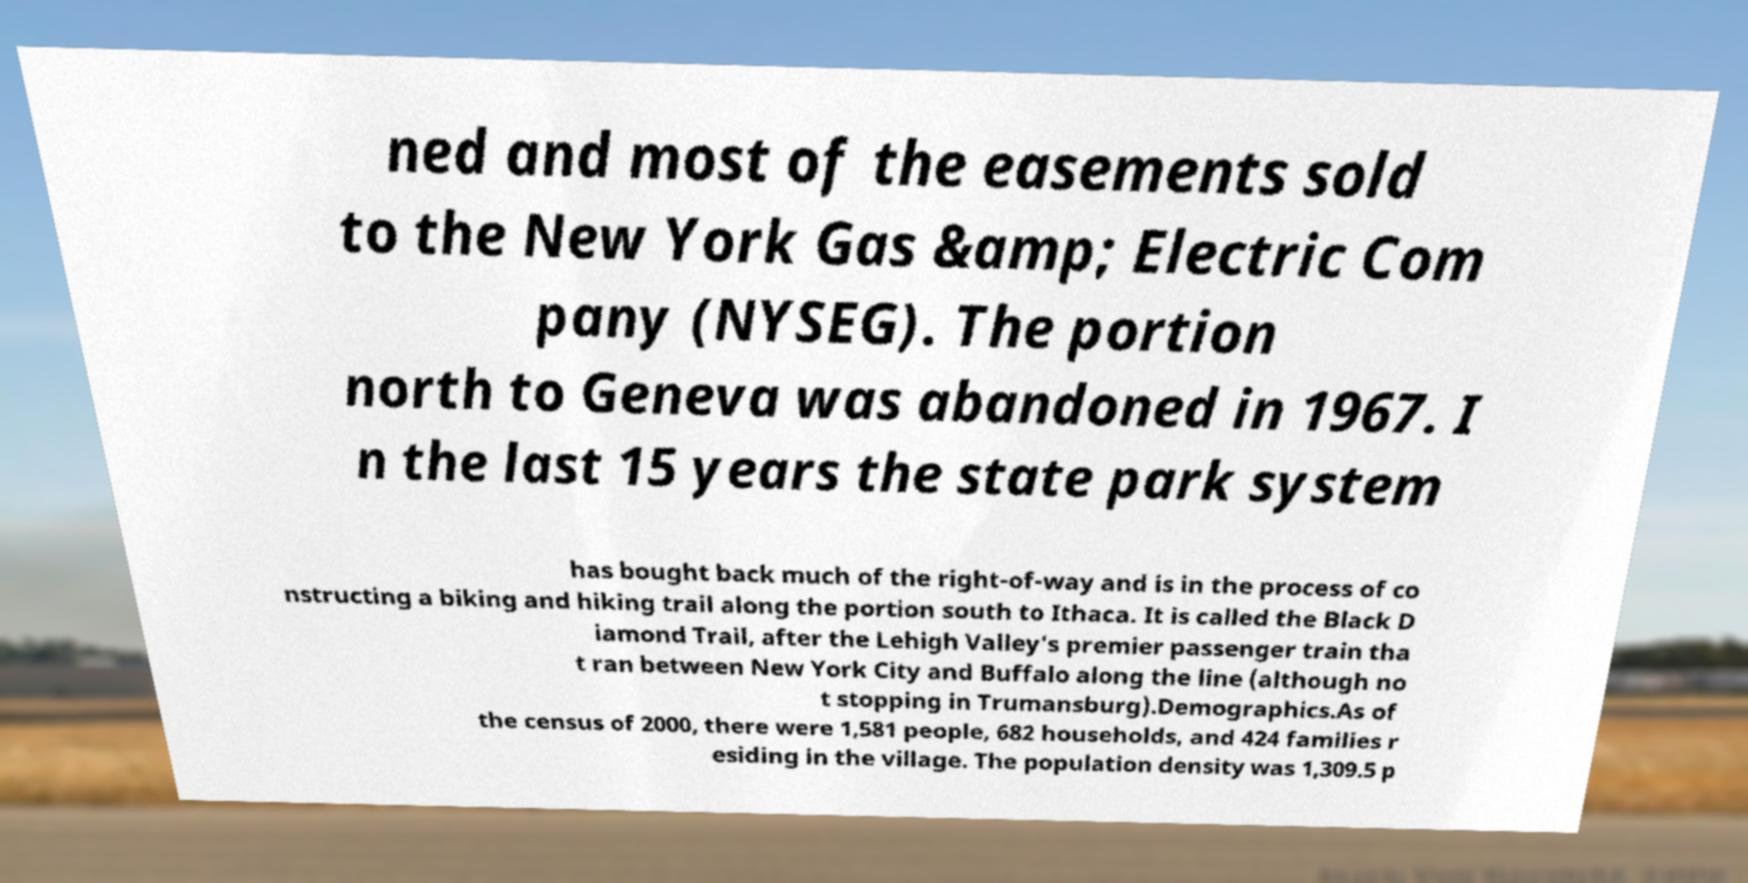Could you assist in decoding the text presented in this image and type it out clearly? ned and most of the easements sold to the New York Gas &amp; Electric Com pany (NYSEG). The portion north to Geneva was abandoned in 1967. I n the last 15 years the state park system has bought back much of the right-of-way and is in the process of co nstructing a biking and hiking trail along the portion south to Ithaca. It is called the Black D iamond Trail, after the Lehigh Valley's premier passenger train tha t ran between New York City and Buffalo along the line (although no t stopping in Trumansburg).Demographics.As of the census of 2000, there were 1,581 people, 682 households, and 424 families r esiding in the village. The population density was 1,309.5 p 